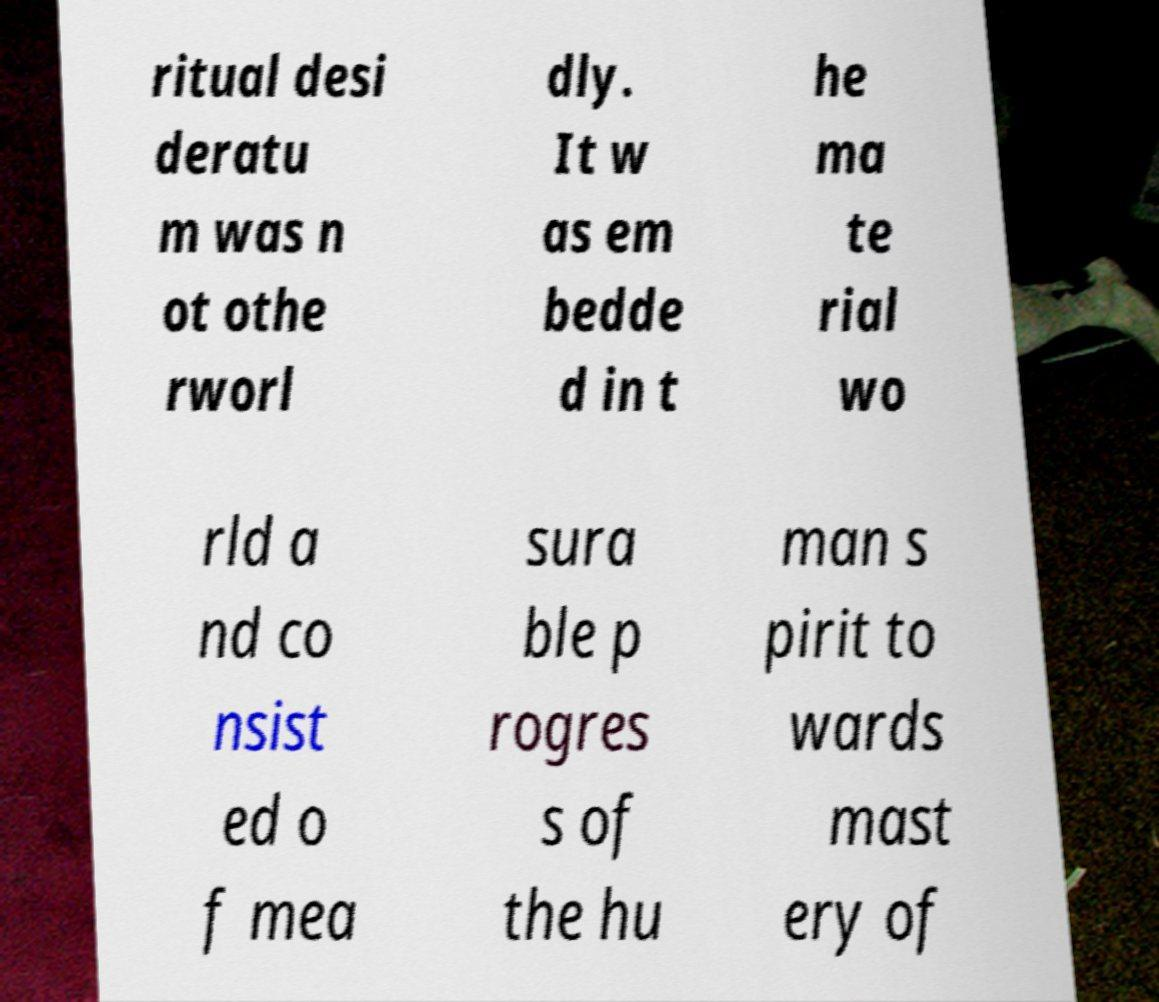There's text embedded in this image that I need extracted. Can you transcribe it verbatim? ritual desi deratu m was n ot othe rworl dly. It w as em bedde d in t he ma te rial wo rld a nd co nsist ed o f mea sura ble p rogres s of the hu man s pirit to wards mast ery of 